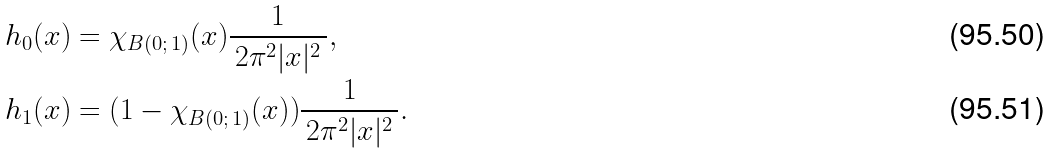Convert formula to latex. <formula><loc_0><loc_0><loc_500><loc_500>h _ { 0 } ( x ) & = \chi _ { B ( 0 ; \, 1 ) } ( x ) \frac { 1 } { \, 2 \pi ^ { 2 } | x | ^ { 2 } \, } , \\ h _ { 1 } ( x ) & = ( 1 - \chi _ { B ( 0 ; \, 1 ) } ( x ) ) \frac { 1 } { \, 2 \pi ^ { 2 } | x | ^ { 2 } \, } .</formula> 